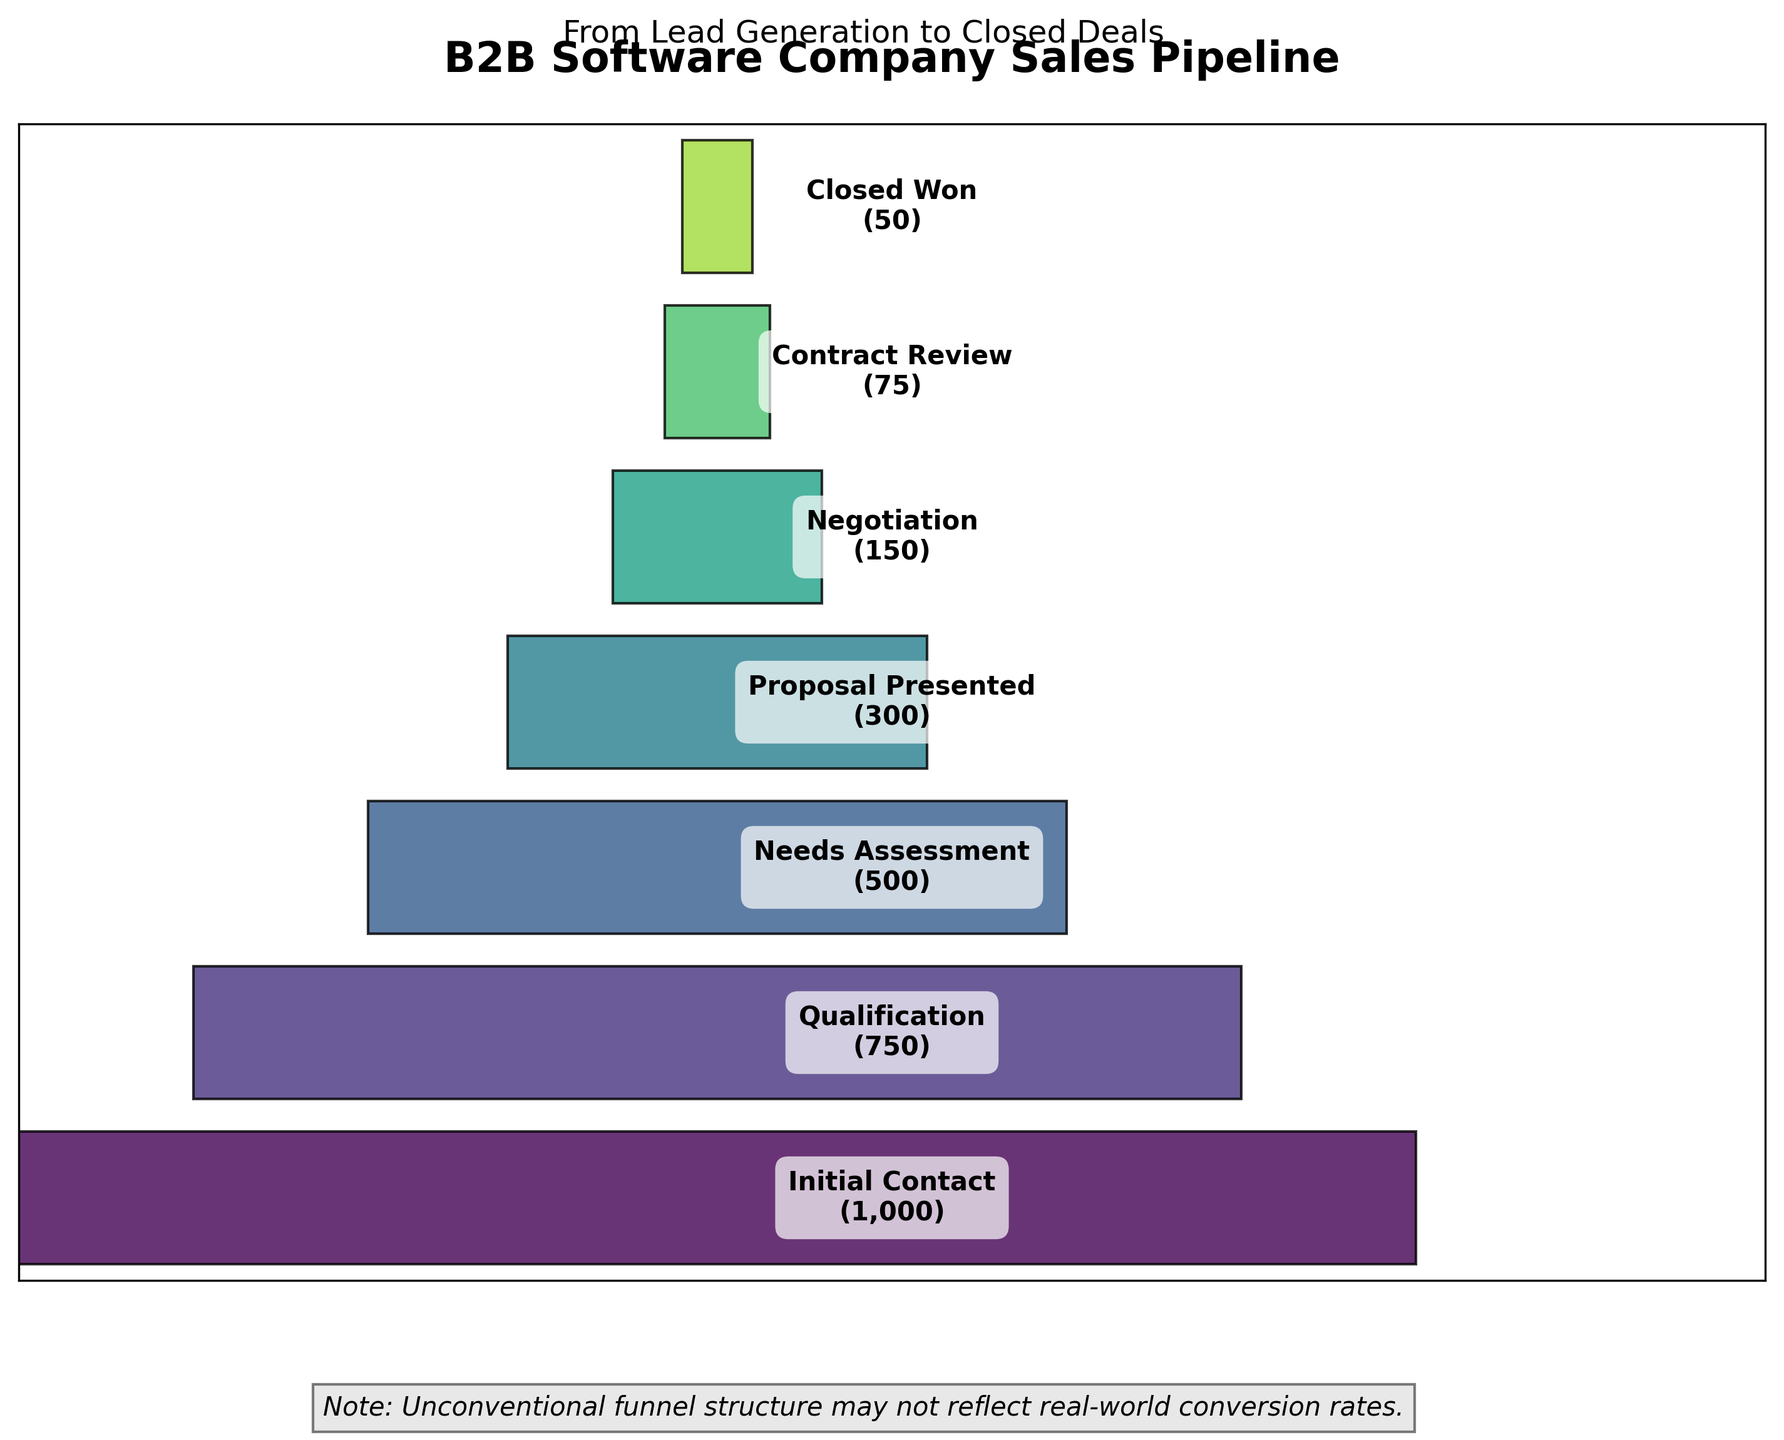What is the title of the funnel chart? The title usually provides an overview of what the chart is about. Here, it is displayed at the top.
Answer: B2B Software Company Sales Pipeline How many stages are there in the sales pipeline? Count the number of distinct segments displayed on the funnel chart. Each is labeled representing different stages.
Answer: 7 Which stage has the highest number of prospects? Look for the segment with the largest width, implying the highest value. This stage is labeled at the top of the funnel.
Answer: Initial Contact What is the number of prospects at the 'Negotiation' stage? Find the segment labeled 'Negotiation'. The number is shown within the segment.
Answer: 150 How many prospects are lost between 'Proposal Presented' and 'Closed Won' stages? Subtract the number of prospects at 'Closed Won' (50) from the number at 'Proposal Presented' (300).
Answer: 250 By what percentage does the prospect count drop from 'Qualification' to 'Needs Assessment'? Calculate the drop (750 - 500 = 250) and divide by the initial value (750), converting the result into a percentage (250/750 * 100%).
Answer: 33.33% Which stage shows the greatest drop in the number of prospects compared to the previous stage? Compare the drop in values between consecutive stages, identify the pair with the biggest difference.
Answer: Proposal Presented to Negotiation If we combine the prospects from the 'Negotiation' and 'Contract Review' stages, how many total prospects are there? Add the number of prospects in 'Negotiation' (150) to those in 'Contract Review' (75).
Answer: 225 What is the average number of prospects across all stages? Sum the number of prospects in all stages (1000 + 750 + 500 + 300 + 150 + 75 + 50 = 2825), then divide by 7 (total stages).
Answer: 403.57 How does the width of the 'Needs Assessment' stage compare to the width of the 'Contract Review' stage? Compare the widths visually. 'Needs Assessment' appears significantly wider than 'Contract Review' due to more prospects.
Answer: Wider 